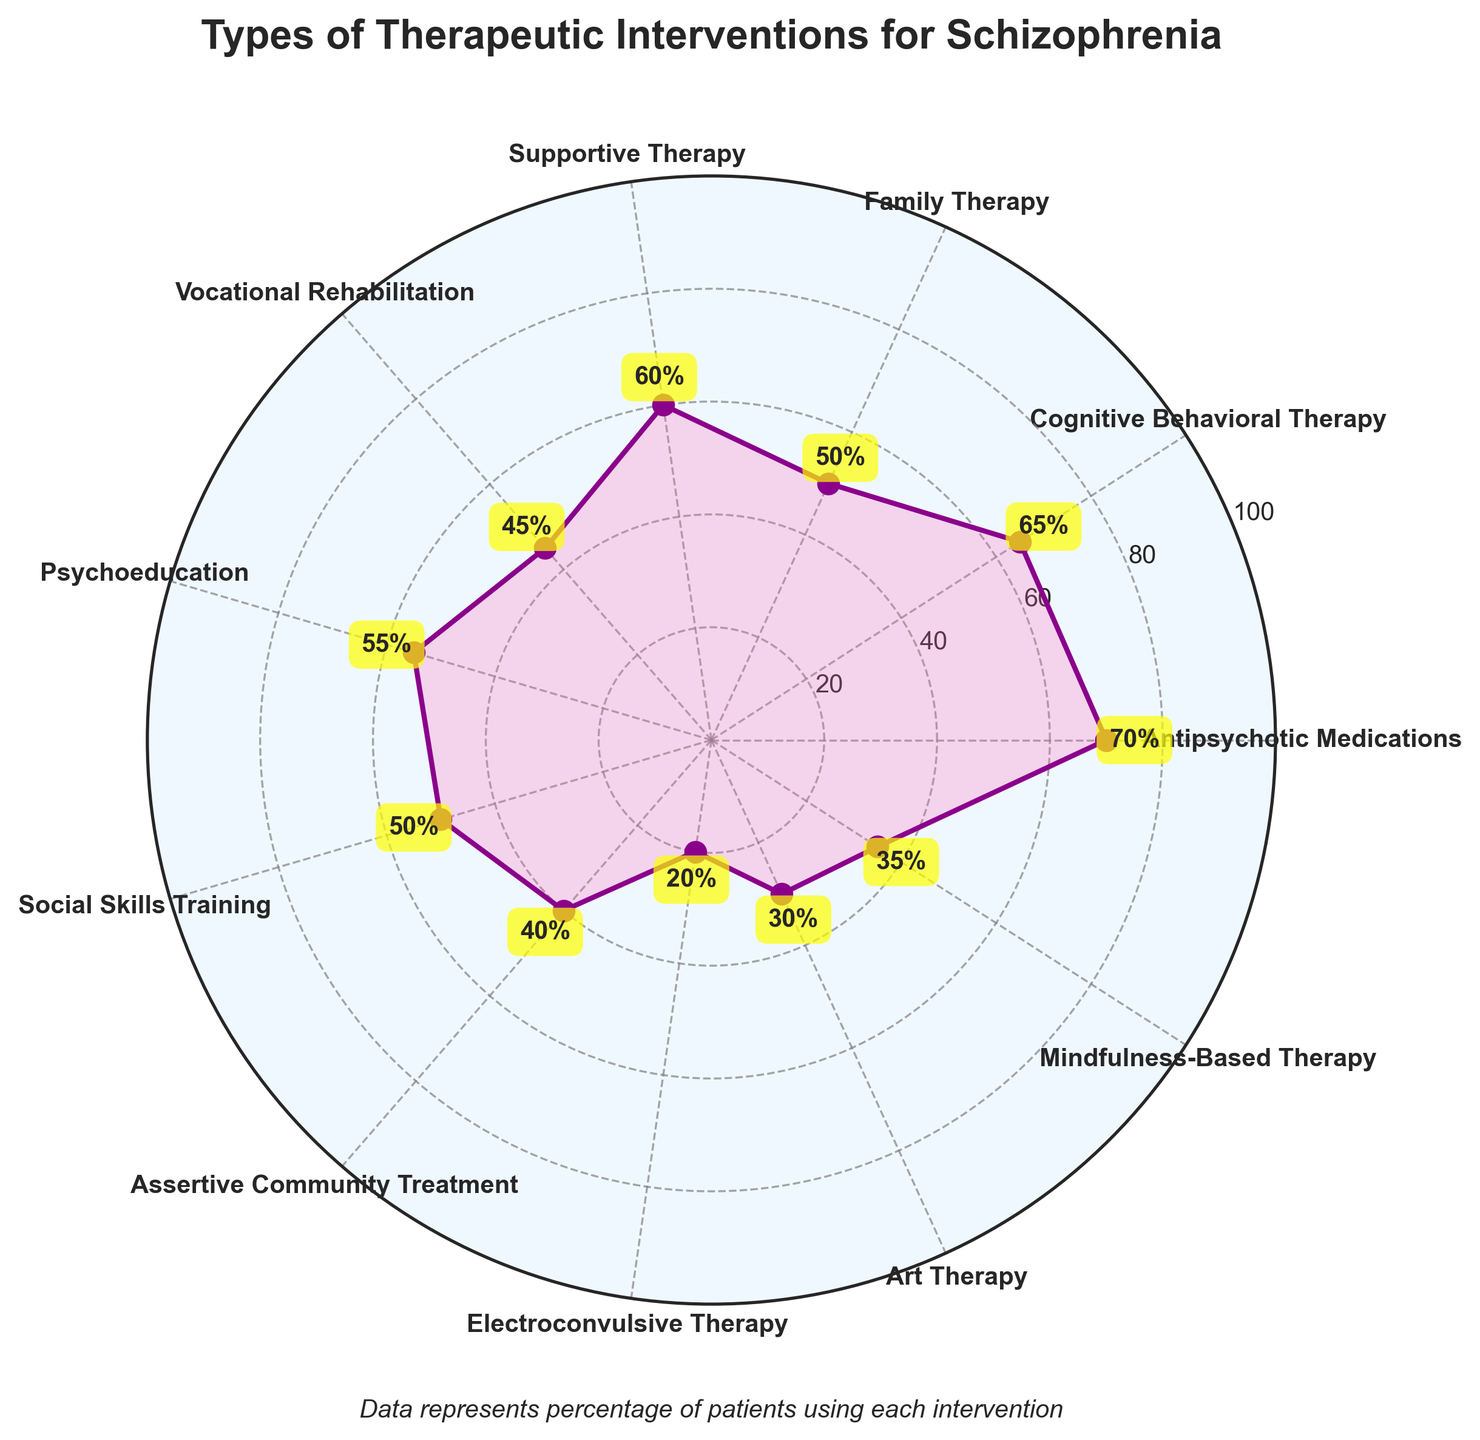What is the title of the figure? The title is typically found at the top of the figure, indicating the overall subject or purpose of the chart.
Answer: Types of Therapeutic Interventions for Schizophrenia Which therapeutic intervention has the highest percentage of use? By looking at the radial distances from the center, we can compare the lengths corresponding to each category. The longest distance indicates the highest percentage.
Answer: Antipsychotic Medications What is the percentage for Electroconvulsive Therapy? You can find the relevant percentage by locating Electroconvulsive Therapy on the polar axis and checking the value displayed next to it.
Answer: 20% How many different types of therapeutic interventions are listed? Count the number of unique labels on the polar axis to determine the number of categories listed. There are labels for each therapeutic intervention.
Answer: 11 How does Family Therapy compare to Supportive Therapy in terms of percentage use? Identify the radial length corresponding to Family Therapy and Supportive Therapy, then compare the numerical values.
Answer: Family Therapy (50%) is lower than Supportive Therapy (60%) What is the average percentage of use for Antipsychotic Medications and Cognitive Behavioral Therapy? First, find the individual percentages for these interventions: Antipsychotic Medications (70%) and Cognitive Behavioral Therapy (65%). Then, calculate the average of these two values: (70 + 65) / 2 = 67.5%
Answer: 67.5% Which interventions have the same percentage of use? Locate the percentages next to each intervention label on the polar axis and find those that match. In this case, Family Therapy and Social Skills Training both have 50%.
Answer: Family Therapy and Social Skills Training What is the percentage difference between the highest and the lowest used interventions? Identify the highest percentage (Antipsychotic Medications at 70%) and the lowest percentage (Electroconvulsive Therapy at 20%), then subtract the smallest value from the largest: 70 - 20 = 50%.
Answer: 50% What does the footnote below the title state? The footnote provides additional context for the data represented in the chart, often found below the main title.
Answer: Data represents percentage of patients using each intervention 